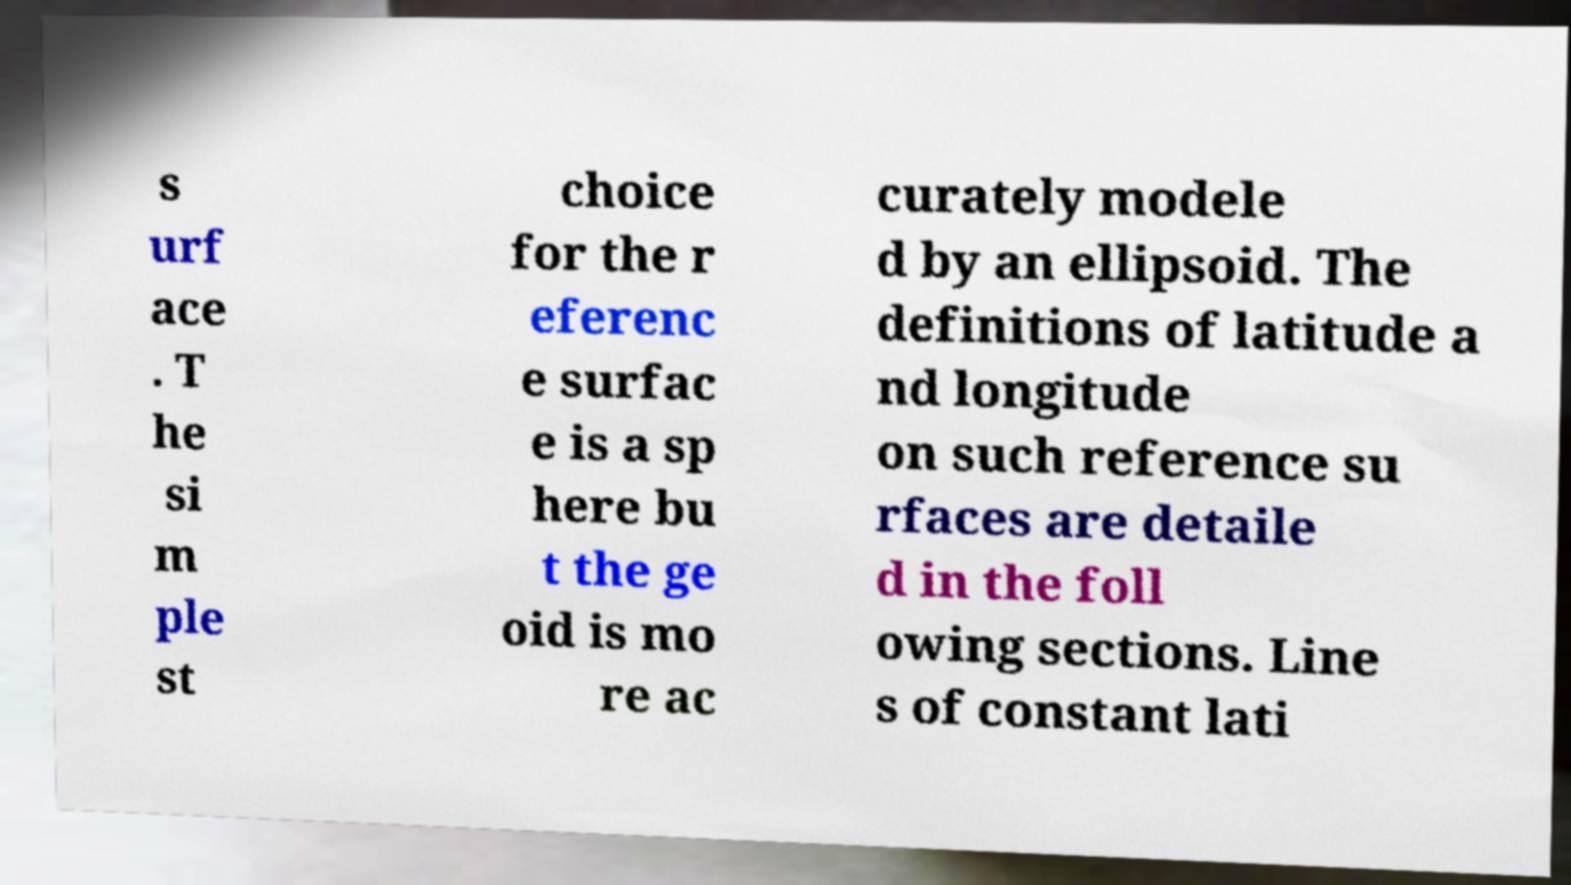Please read and relay the text visible in this image. What does it say? s urf ace . T he si m ple st choice for the r eferenc e surfac e is a sp here bu t the ge oid is mo re ac curately modele d by an ellipsoid. The definitions of latitude a nd longitude on such reference su rfaces are detaile d in the foll owing sections. Line s of constant lati 